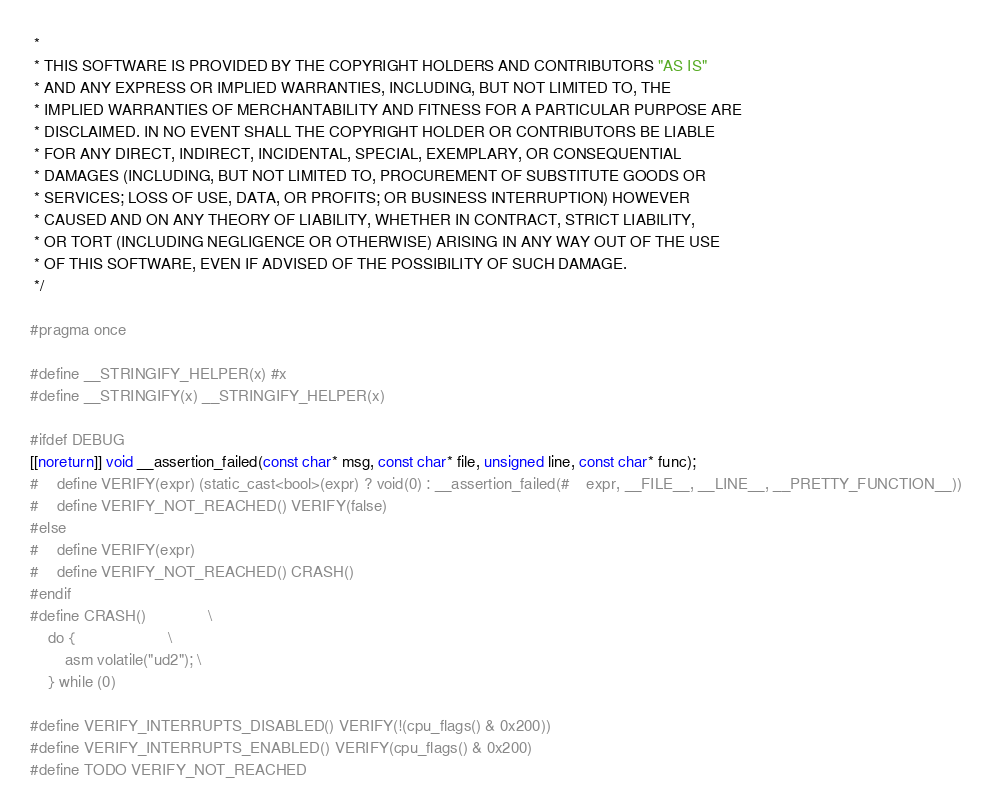Convert code to text. <code><loc_0><loc_0><loc_500><loc_500><_C_> *
 * THIS SOFTWARE IS PROVIDED BY THE COPYRIGHT HOLDERS AND CONTRIBUTORS "AS IS"
 * AND ANY EXPRESS OR IMPLIED WARRANTIES, INCLUDING, BUT NOT LIMITED TO, THE
 * IMPLIED WARRANTIES OF MERCHANTABILITY AND FITNESS FOR A PARTICULAR PURPOSE ARE
 * DISCLAIMED. IN NO EVENT SHALL THE COPYRIGHT HOLDER OR CONTRIBUTORS BE LIABLE
 * FOR ANY DIRECT, INDIRECT, INCIDENTAL, SPECIAL, EXEMPLARY, OR CONSEQUENTIAL
 * DAMAGES (INCLUDING, BUT NOT LIMITED TO, PROCUREMENT OF SUBSTITUTE GOODS OR
 * SERVICES; LOSS OF USE, DATA, OR PROFITS; OR BUSINESS INTERRUPTION) HOWEVER
 * CAUSED AND ON ANY THEORY OF LIABILITY, WHETHER IN CONTRACT, STRICT LIABILITY,
 * OR TORT (INCLUDING NEGLIGENCE OR OTHERWISE) ARISING IN ANY WAY OUT OF THE USE
 * OF THIS SOFTWARE, EVEN IF ADVISED OF THE POSSIBILITY OF SUCH DAMAGE.
 */

#pragma once

#define __STRINGIFY_HELPER(x) #x
#define __STRINGIFY(x) __STRINGIFY_HELPER(x)

#ifdef DEBUG
[[noreturn]] void __assertion_failed(const char* msg, const char* file, unsigned line, const char* func);
#    define VERIFY(expr) (static_cast<bool>(expr) ? void(0) : __assertion_failed(#    expr, __FILE__, __LINE__, __PRETTY_FUNCTION__))
#    define VERIFY_NOT_REACHED() VERIFY(false)
#else
#    define VERIFY(expr)
#    define VERIFY_NOT_REACHED() CRASH()
#endif
#define CRASH()              \
    do {                     \
        asm volatile("ud2"); \
    } while (0)

#define VERIFY_INTERRUPTS_DISABLED() VERIFY(!(cpu_flags() & 0x200))
#define VERIFY_INTERRUPTS_ENABLED() VERIFY(cpu_flags() & 0x200)
#define TODO VERIFY_NOT_REACHED
</code> 